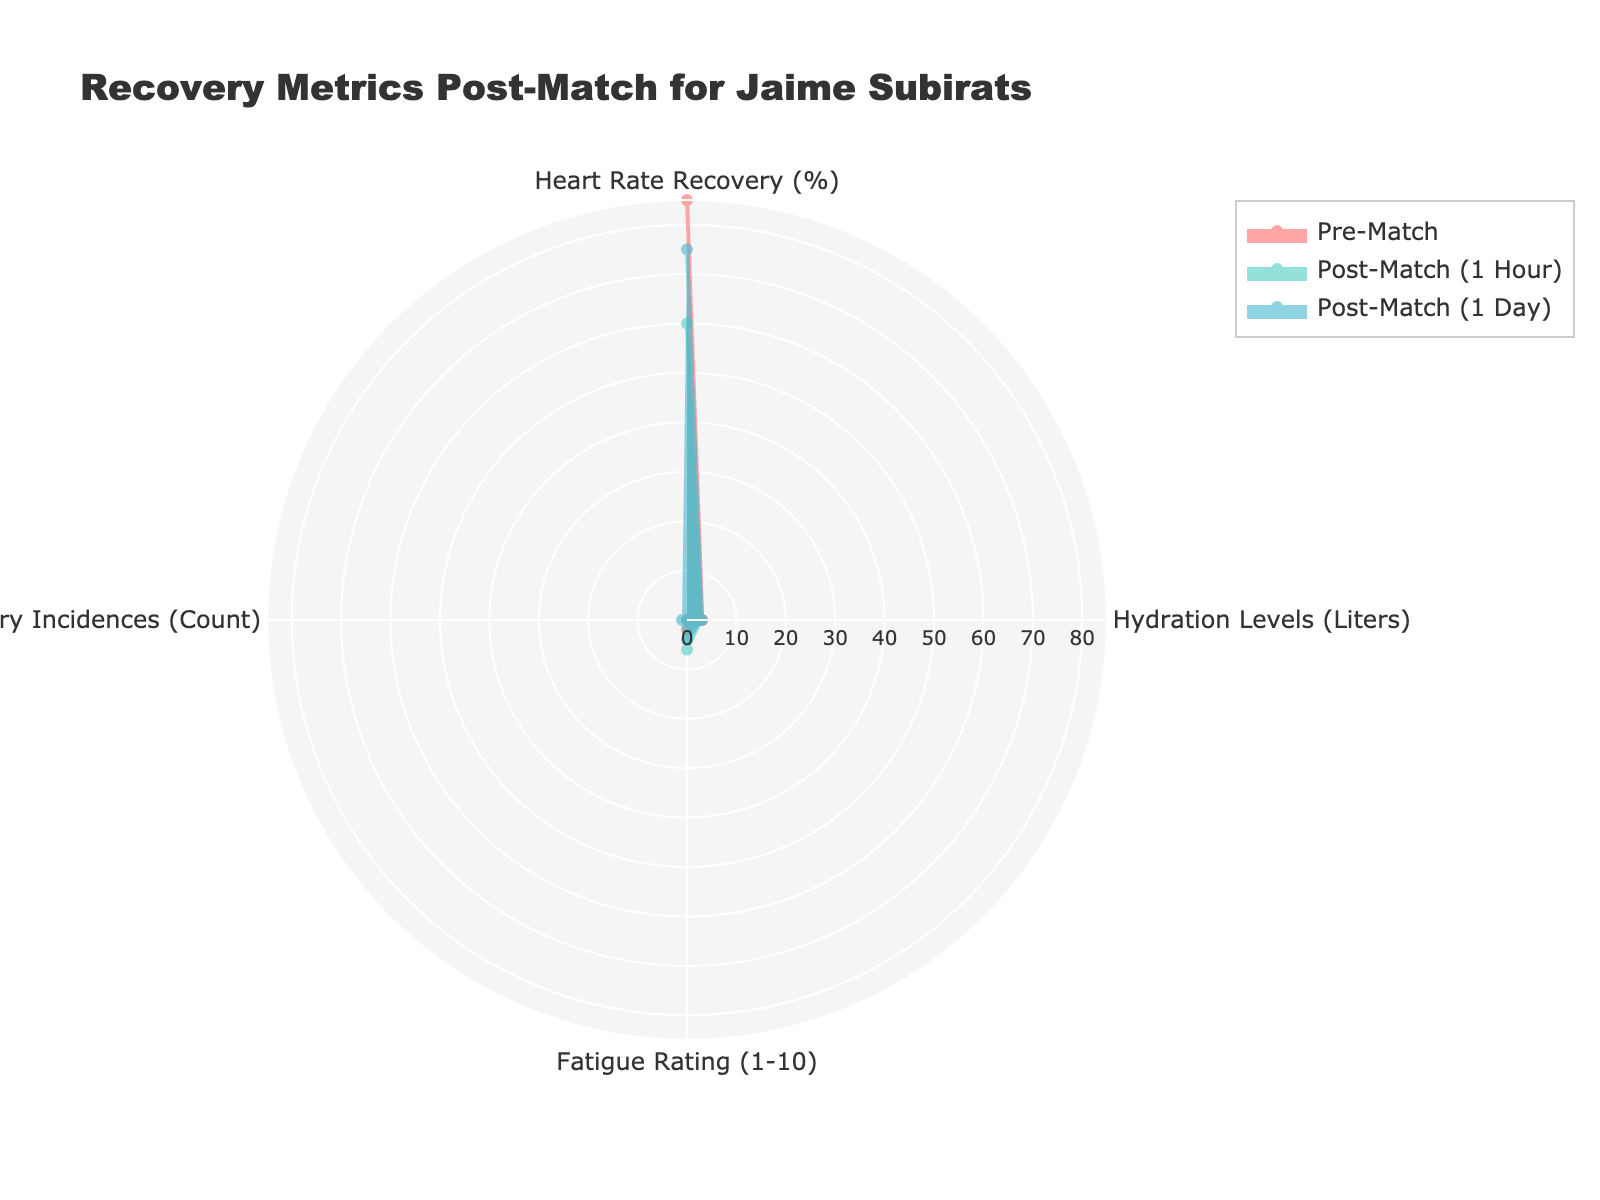What is the title of the figure? The title is typically located at the top of the figure and provides a concise description of what the figure represents.
Answer: Recovery Metrics Post-Match for Jaime Subirats Which group has the lowest Heart Rate Recovery percentage? By visually inspecting the radar chart, identify which group corresponds to the smallest value on the Heart Rate Recovery axis.
Answer: Post-Match (1 Hour) How does Fatigue Rating change from Pre-Match to Post-Match (1 Day)? Compare the Fatigue Rating values on the radar chart for Pre-Match and Post-Match (1 Day) and note the difference in their positions on the axis.
Answer: It increases from 2 to 4 What is the difference in Hydration Levels between Post-Match (1 Hour) and Post-Match (1 Day)? Locate the Hydration Level values for both groups on the radar chart, then subtract the value of Post-Match (1 Hour) from that of Post-Match (1 Day).
Answer: 0.2 Liters Which group has the highest value for Heart Rate Recovery? Look for the group whose data point reaches the highest position on the Heart Rate Recovery axis of the radar chart.
Answer: Post-Match (1 Week) How many Injury Incidences are reported in Post-Match (1 Day)? Locate the value on the Injury Incidences axis for the Post-Match (1 Day) group on the radar chart.
Answer: 1 What is the average Heart Rate Recovery value for the first three groups? Sum the Heart Rate Recovery percentages for Pre-Match, Post-Match (1 Hour), and Post-Match (1 Day), then divide by 3.
Answer: (85 + 60 + 75) / 3 = 73.3% Which group has the lowest Fatigue Rating? Identify the group whose data point is positioned lowest on the Fatigue Rating axis.
Answer: Post-Match (1 Week) Compare the Hydration Levels between Pre-Match and Post-Match (1 Week). Which is higher? Visually compare the positions of Pre-Match and Post-Match (1 Week) on the Hydration Levels axis; determine which one is higher.
Answer: Post-Match (1 Week) Which metric shows the most significant decline from Pre-Match to Post-Match (1 Hour)? Analyze all four metrics and identify which one decreases the most in value from Pre-Match to Post-Match (1 Hour).
Answer: Heart Rate Recovery 